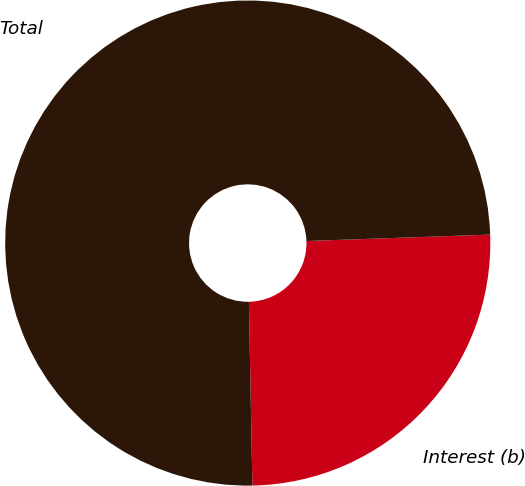Convert chart to OTSL. <chart><loc_0><loc_0><loc_500><loc_500><pie_chart><fcel>Interest (b)<fcel>Total<nl><fcel>25.25%<fcel>74.75%<nl></chart> 